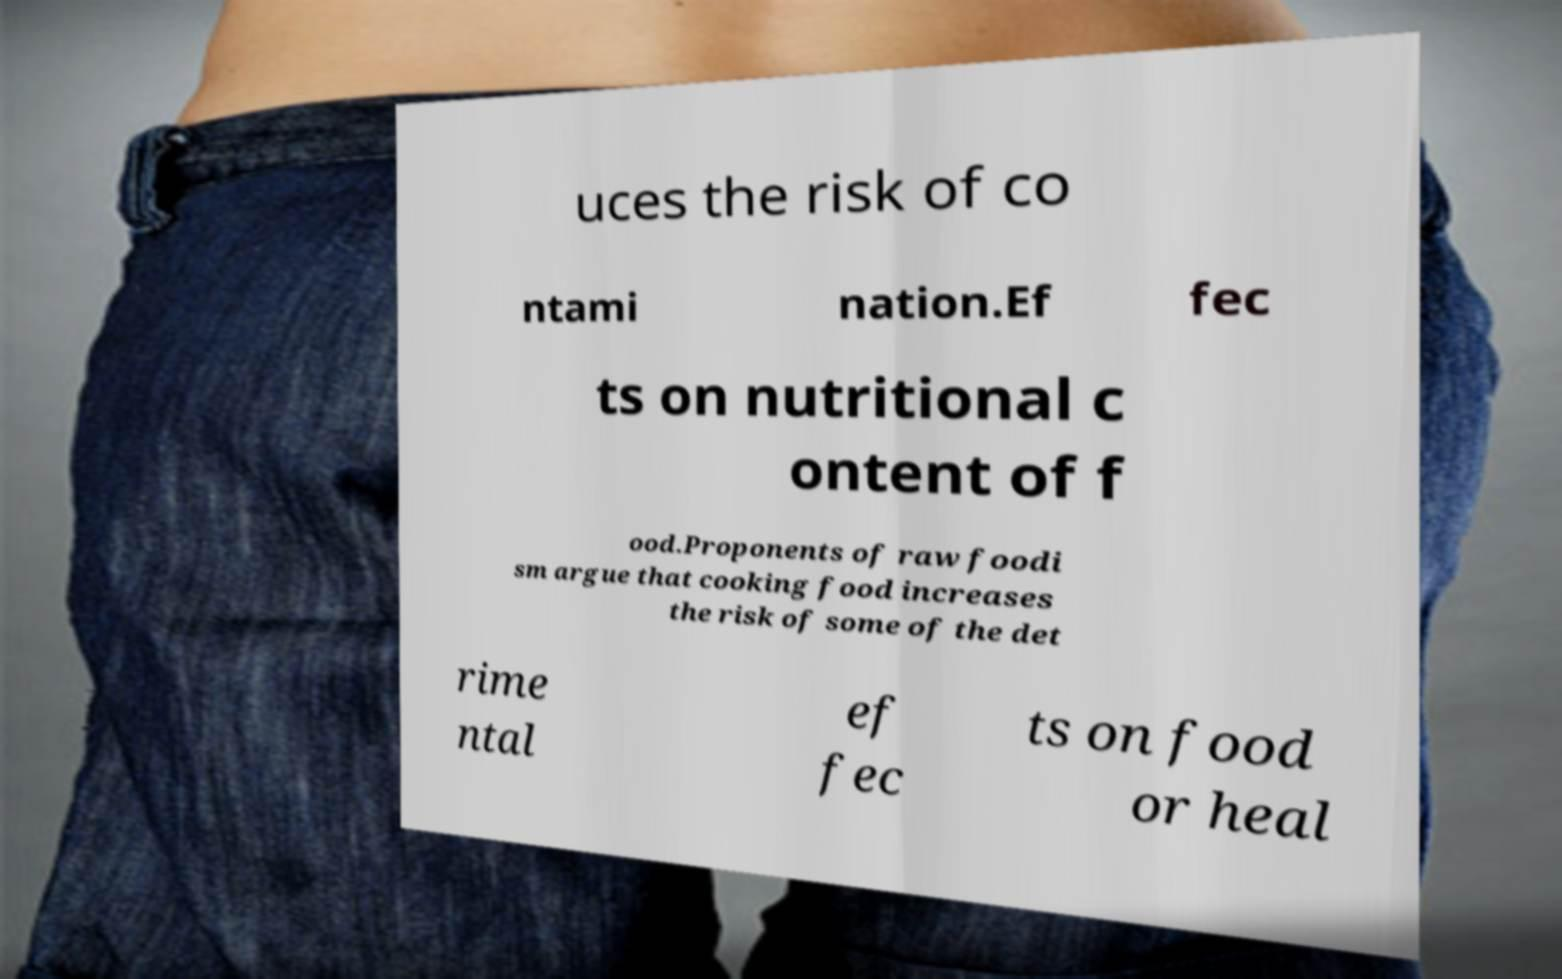For documentation purposes, I need the text within this image transcribed. Could you provide that? uces the risk of co ntami nation.Ef fec ts on nutritional c ontent of f ood.Proponents of raw foodi sm argue that cooking food increases the risk of some of the det rime ntal ef fec ts on food or heal 